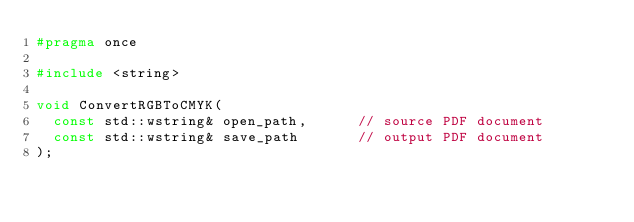<code> <loc_0><loc_0><loc_500><loc_500><_C_>#pragma once

#include <string>

void ConvertRGBToCMYK(
  const std::wstring& open_path,      // source PDF document
  const std::wstring& save_path       // output PDF document
);
</code> 